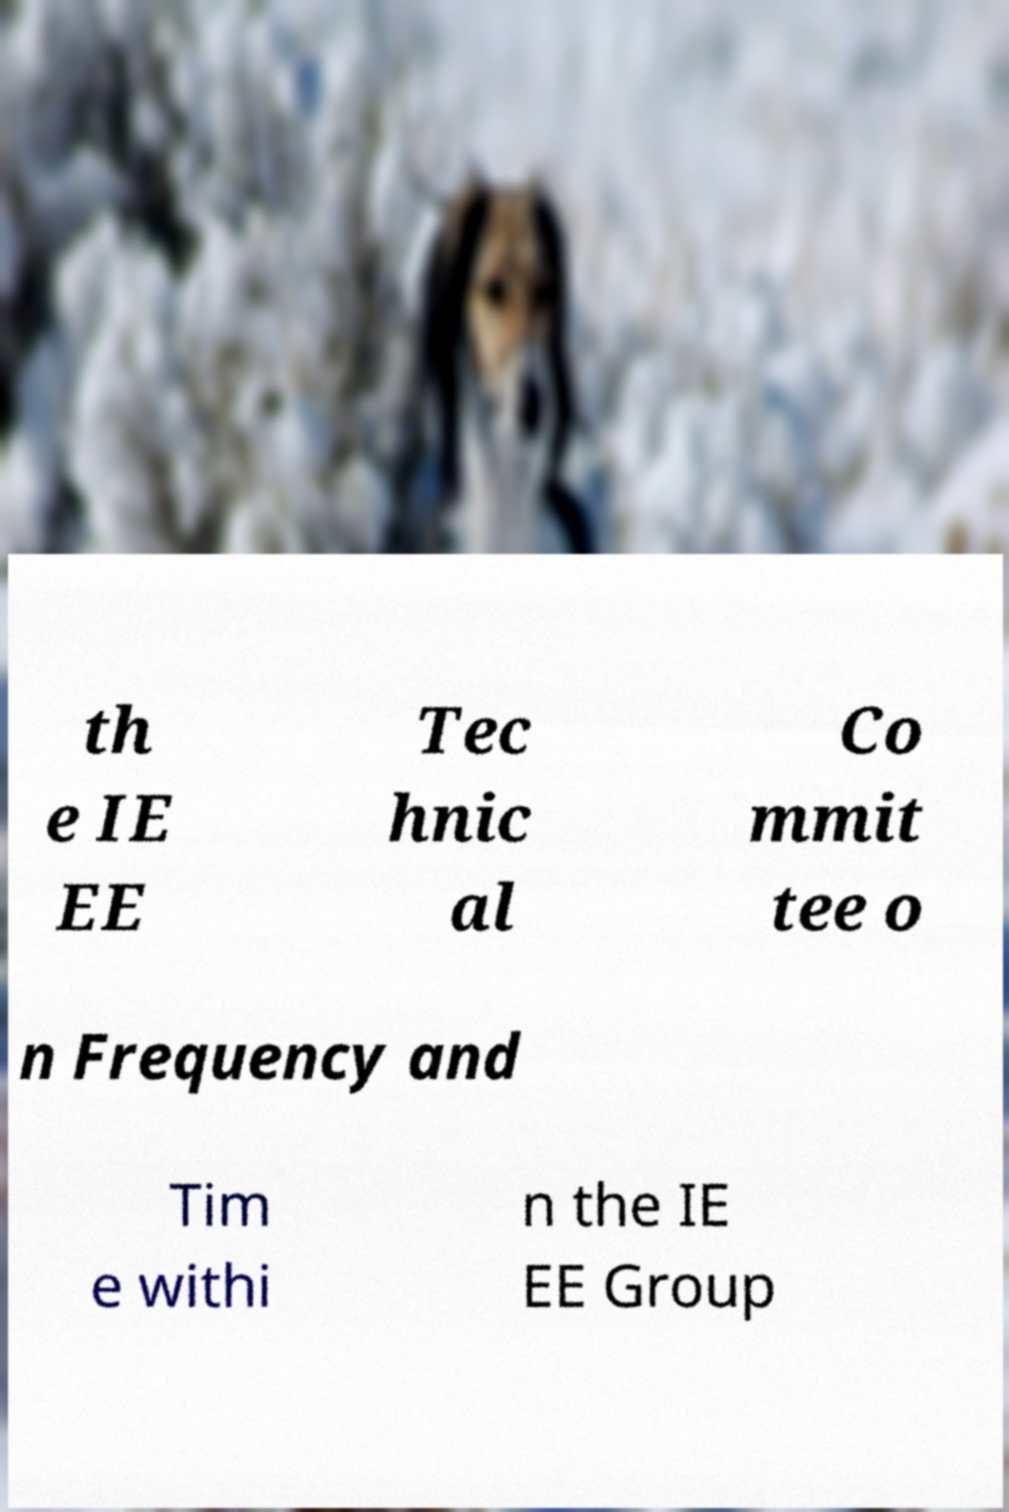I need the written content from this picture converted into text. Can you do that? th e IE EE Tec hnic al Co mmit tee o n Frequency and Tim e withi n the IE EE Group 